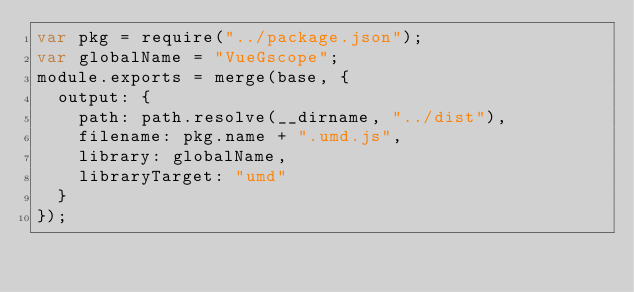<code> <loc_0><loc_0><loc_500><loc_500><_JavaScript_>var pkg = require("../package.json");
var globalName = "VueGscope";
module.exports = merge(base, {
	output: {
		path: path.resolve(__dirname, "../dist"),
		filename: pkg.name + ".umd.js",
		library: globalName,
		libraryTarget: "umd"
	}
});
</code> 